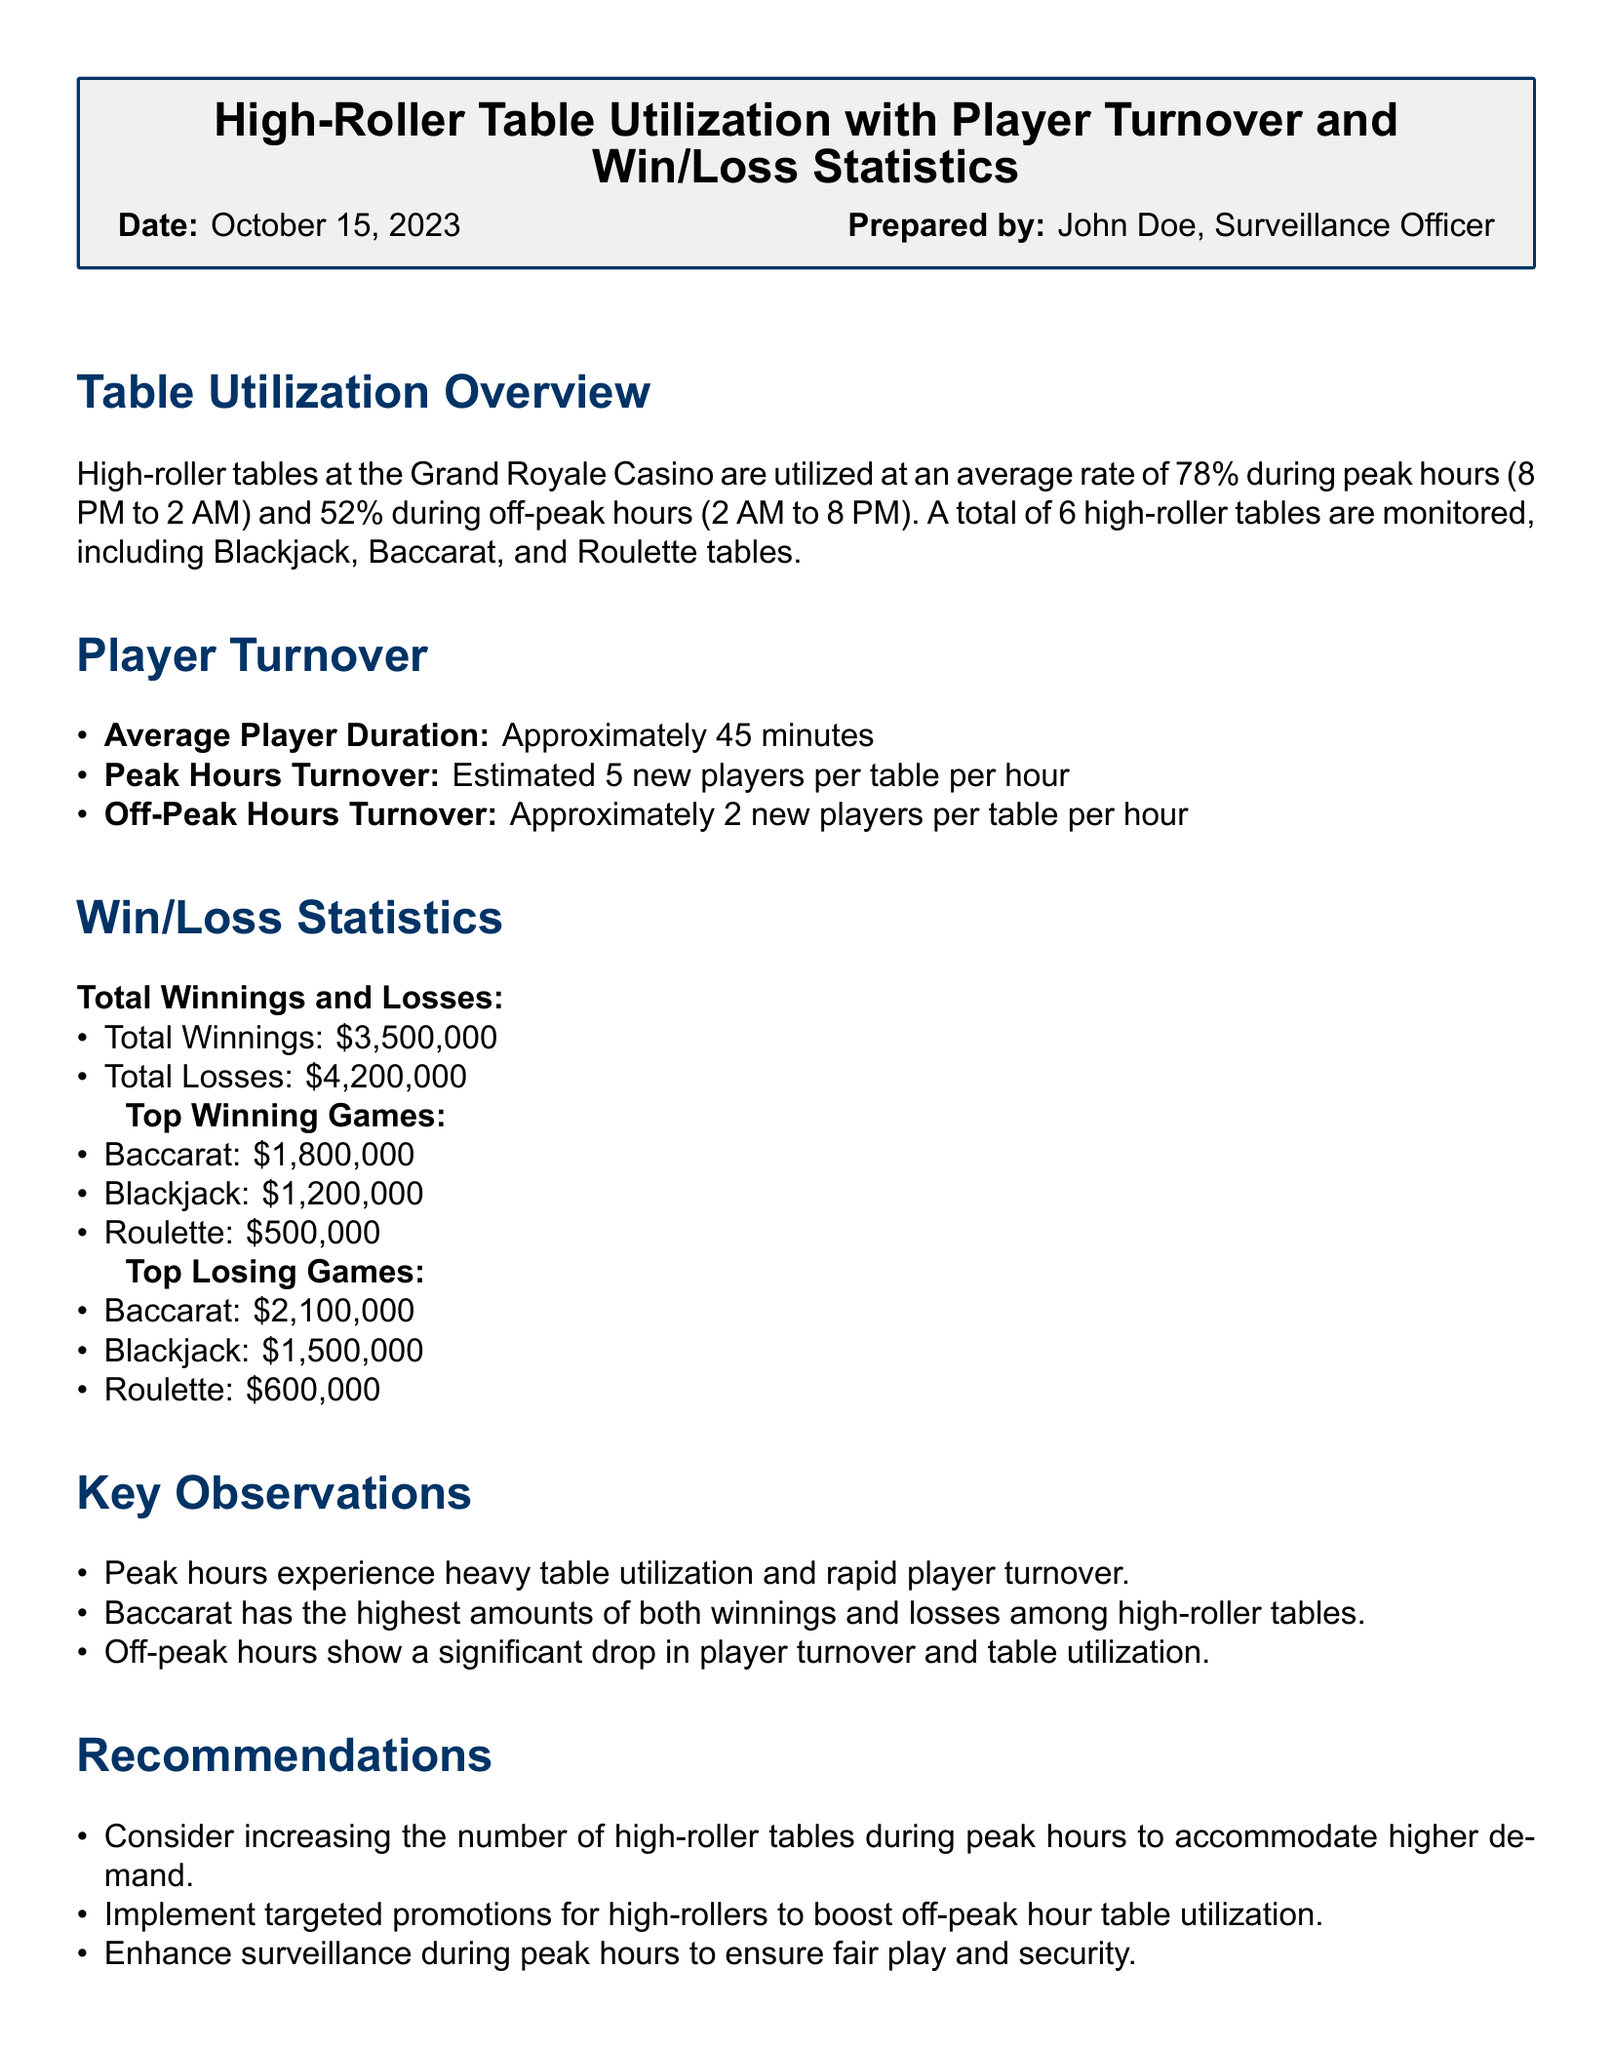What is the average table utilization during peak hours? The document states that high-roller tables are utilized at an average rate of 78% during peak hours.
Answer: 78% What is the average player duration at the high-roller tables? The document indicates that the average player duration is approximately 45 minutes.
Answer: 45 minutes How many high-roller tables are monitored at the casino? The report mentions that a total of 6 high-roller tables are monitored.
Answer: 6 Which game has the highest total winnings? According to the statistics, Baccarat has the highest total winnings of $1,800,000.
Answer: Baccarat What is the total loss amount reported? The document lists the total losses as $4,200,000.
Answer: $4,200,000 During off-peak hours, how many new players are estimated per table per hour? The report states that approximately 2 new players are estimated per table per hour during off-peak hours.
Answer: 2 What is a key observation about peak hours? The document notes that peak hours experience heavy table utilization and rapid player turnover.
Answer: Heavy table utilization and rapid player turnover What is a recommendation mentioned for off-peak hours? The report suggests implementing targeted promotions for high-rollers to boost off-peak hour table utilization.
Answer: Targeted promotions for high-rollers Which game reported the highest losses? The document shows that Baccarat reported the highest losses of $2,100,000.
Answer: Baccarat 